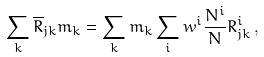Convert formula to latex. <formula><loc_0><loc_0><loc_500><loc_500>\sum _ { k } \overline { R } _ { j k } m _ { k } = \sum _ { k } m _ { k } \sum _ { i } w ^ { i } \frac { N ^ { i } } { N } R ^ { i } _ { j k } \, ,</formula> 